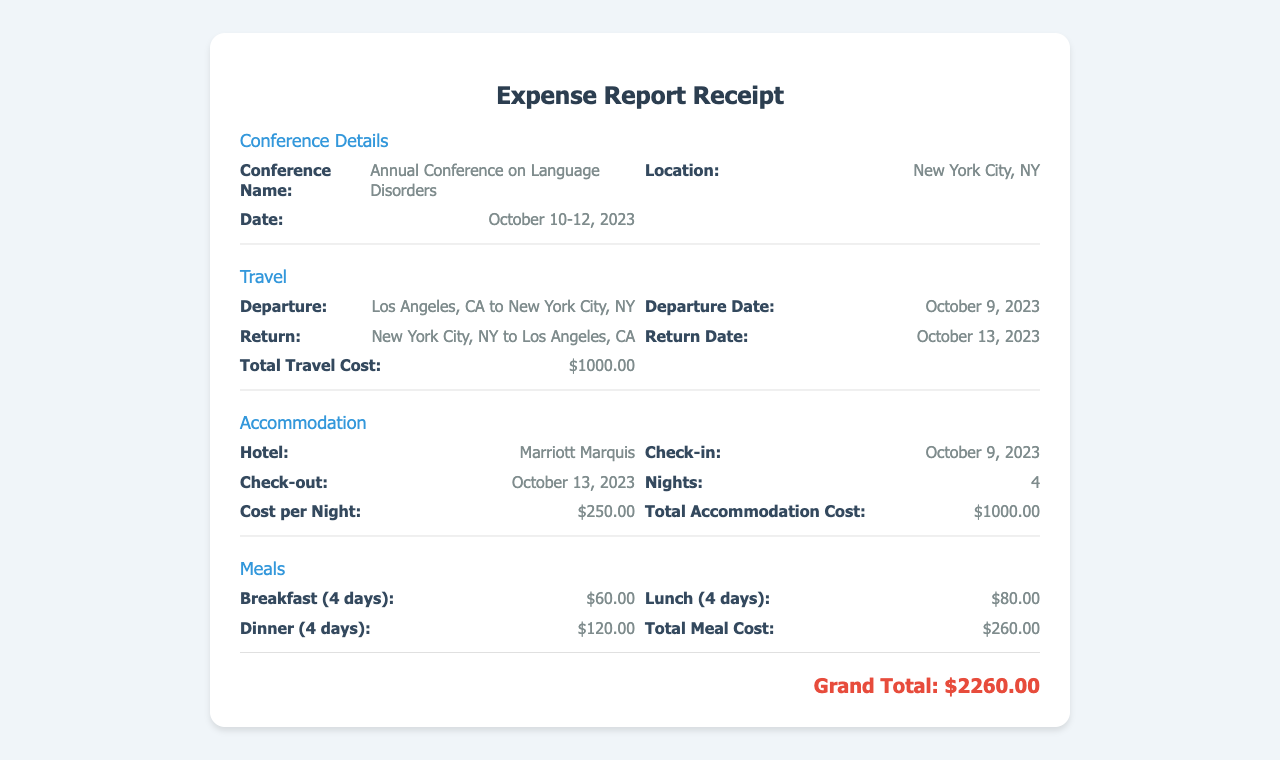What is the conference name? The conference name is stated in the document under Conference Details, which is the "Annual Conference on Language Disorders."
Answer: Annual Conference on Language Disorders What is the total travel cost? The document specifies the total travel cost in the Travel section, which is $1000.00.
Answer: $1000.00 Where is the conference located? The location of the conference is mentioned in the Conference Details section as New York City, NY.
Answer: New York City, NY How many nights did the accommodation last? The number of nights can be found in the Accommodation section, which indicates there were 4 nights.
Answer: 4 What is the total meal cost? The total meal cost is found in the Meals section of the document, which sums to $260.00.
Answer: $260.00 What hotel was used for accommodation? The hotel name is provided in the Accommodation section, which is "Marriott Marquis."
Answer: Marriott Marquis When did the conference take place? The dates for the conference are located in the Conference Details section, which are October 10-12, 2023.
Answer: October 10-12, 2023 What was the cost per night for accommodation? The document specifies the cost per night in the Accommodation section as $250.00.
Answer: $250.00 What is the grand total of the expenses? The grand total is calculated at the bottom of the document, combining all costs, which is $2260.00.
Answer: $2260.00 